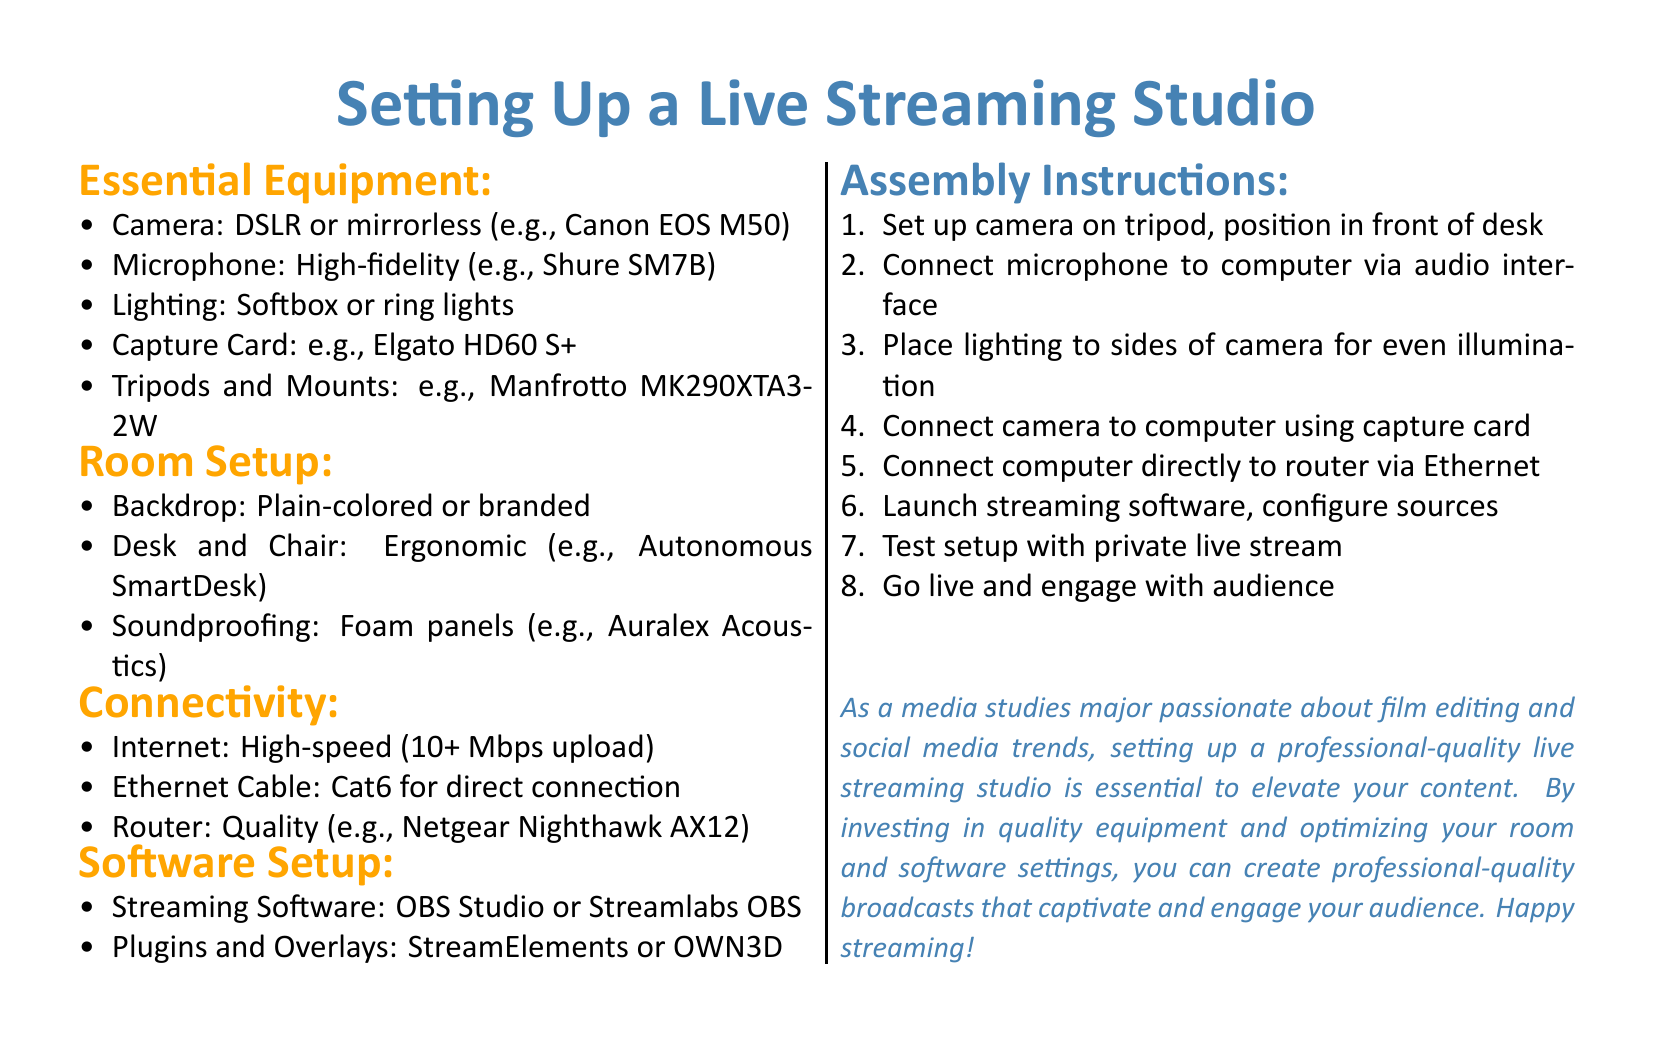What is the recommended camera type? The document specifies that a DSLR or mirrorless camera is recommended, with a specific example provided (Canon EOS M50).
Answer: DSLR or mirrorless (e.g., Canon EOS M50) What should the internet speed be for streaming? The document states that high-speed internet with an upload speed of 10+ Mbps is required for effective streaming.
Answer: 10+ Mbps upload Name one type of lighting suggested in the document. The document mentions softbox or ring lights as example types of lighting to use in the studio setup.
Answer: Softbox or ring lights How should the backdrop be described? According to the document, the backdrop can be plain-colored or branded, providing options for customization.
Answer: Plain-colored or branded What is the first step in the assembly instructions? The document outlines that the first step is to set up the camera on the tripod and position it in front of the desk.
Answer: Set up camera on tripod, position in front of desk Which streaming software is recommended? The document lists OBS Studio or Streamlabs OBS as recommended streaming software options.
Answer: OBS Studio or Streamlabs OBS What type of cable is needed for a direct connection to the router? A Cat6 Ethernet cable is mentioned in the document as necessary for a direct connection to the router.
Answer: Cat6 What are the soundproofing materials suggested? It suggests using foam panels, specifically mentioning Auralex Acoustics as a type of soundproofing material.
Answer: Foam panels (e.g., Auralex Acoustics) What is the document's main focus? The document is primarily focused on providing assembly instructions for setting up a live streaming studio for professional-quality broadcasts.
Answer: Assembly instructions for professional-quality broadcasts 